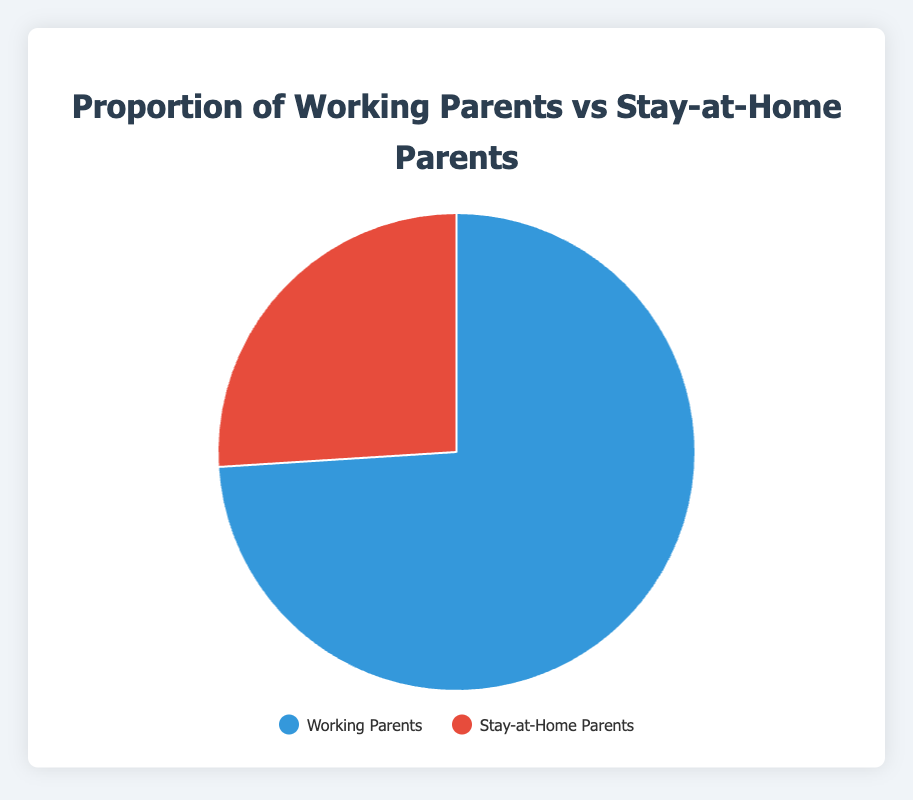What proportion of parents are working parents? The chart shows two categories: Working Parents and Stay-at-Home Parents. The proportion of Working Parents is represented by the percentage next to their label.
Answer: 74% What proportion of parents stay at home? Look at the Stay-at-Home Parents category and observe the percentage noted next to it.
Answer: 26% How much larger is the proportion of Working Parents compared to Stay-at-Home Parents? To find this, subtract the percentage of Stay-at-Home Parents from the percentage of Working Parents: 74% - 26% = 48%.
Answer: 48% Which category has the fewer percentage, and by how much? The category with the lower percentage is Stay-at-Home Parents at 26%. To find by how much, subtract Stay-at-Home Parents' percentage from Working Parents' percentage: 74% - 26% = 48%.
Answer: Stay-at-Home Parents by 48% If you combine both categories, what is the total percentage? Adding the percentages of both categories: 74% (Working Parents) + 26% (Stay-at-Home Parents) = 100%.
Answer: 100% What percentage of the pie chart does the red segment represent? The red segment represents the Stay-at-Home Parents which is 26%.
Answer: 26% Which category is represented by the blue segment and what is its percentage? The blue segment represents the Working Parents with a percentage of 74%.
Answer: Working Parents, 74% By how much does the proportion of Working Parents exceed the halfway mark of the pie chart? First, find the halfway mark which is 50%. Then, subtract it from the proportion of Working Parents: 74% - 50% = 24%.
Answer: 24% 